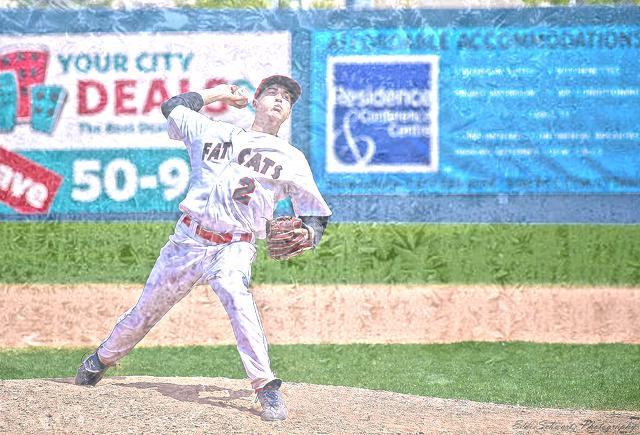Can you describe the player's uniform? Certainly, the player is wearing a white uniform with red accents and the word 'FAN CATS' across the chest. The number 12 is also visible on the shirt. Is there any significance to the uniform colors? The uniform colors are typically chosen to represent the team's branding and identity. Red and white are common colors that may symbolize energy, passion, and unity for the team. 